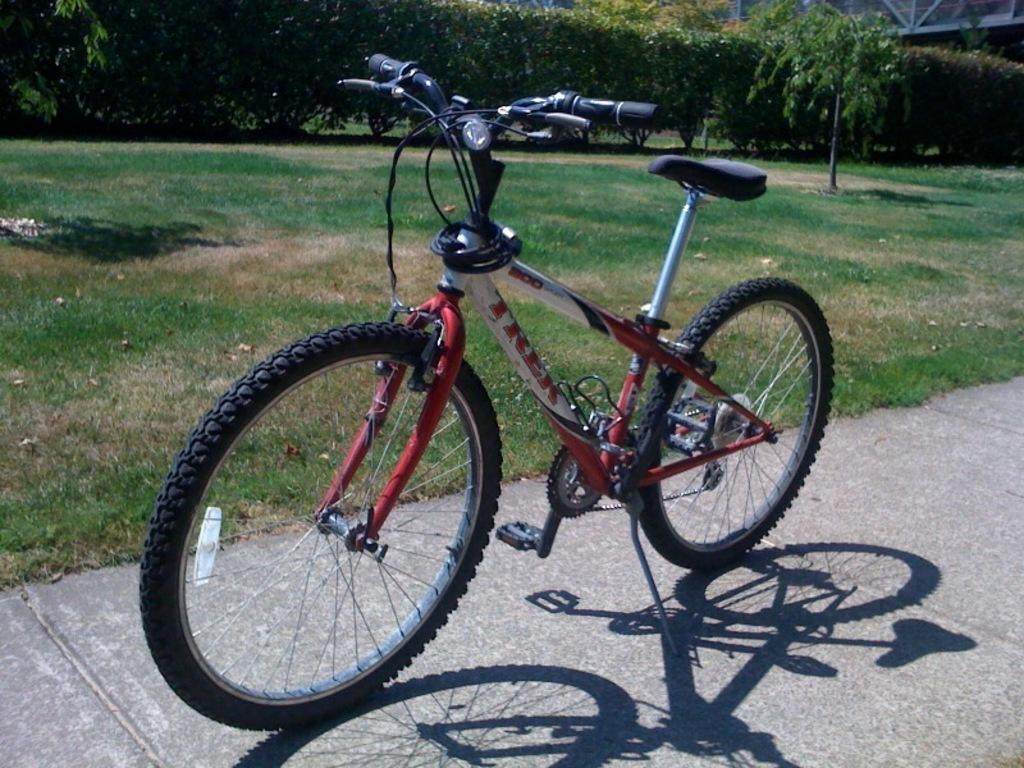How would you summarize this image in a sentence or two? In this image we can see a bicycle, which is of red and white in color and it is parked on the side path. In the background we can see grass and a lots of plants. 